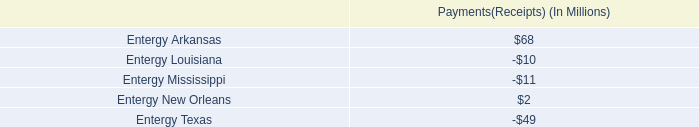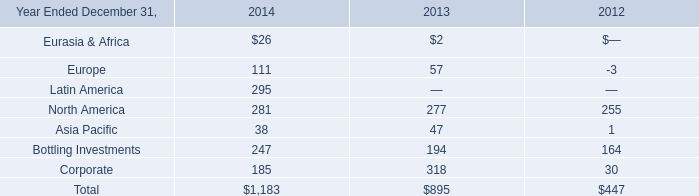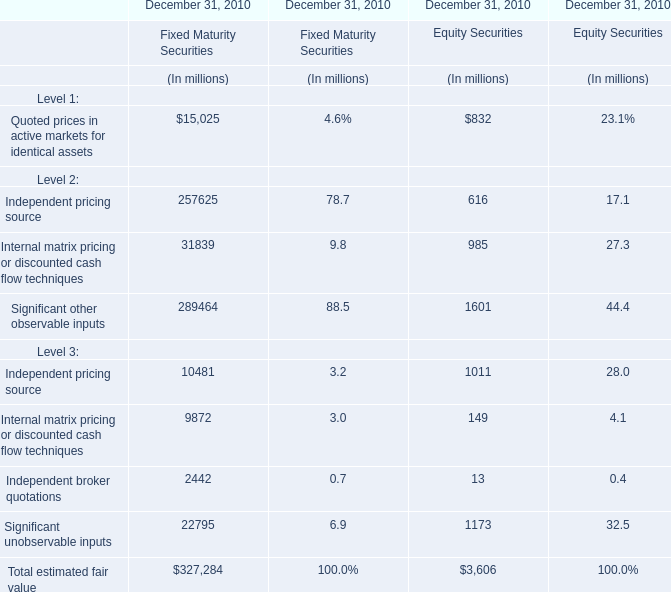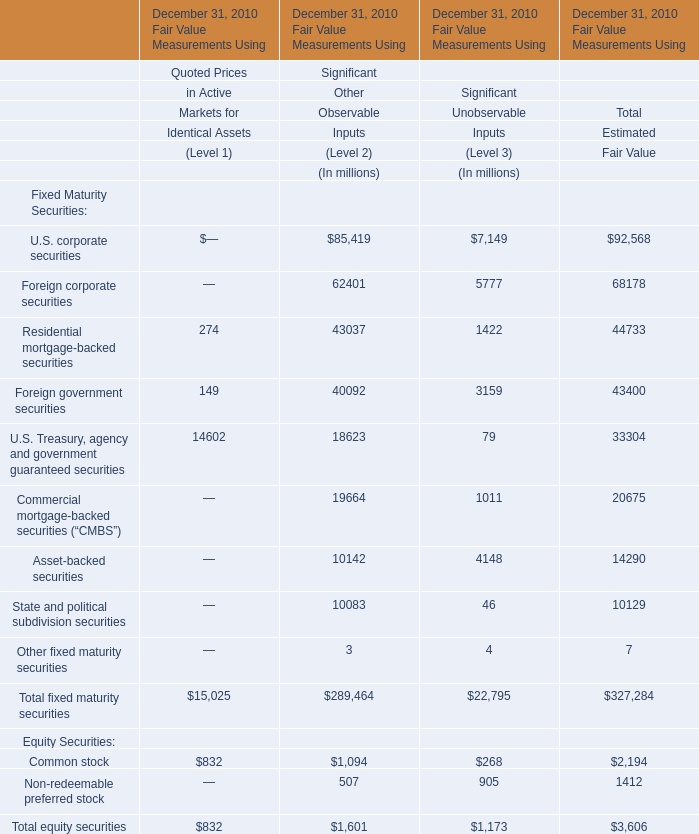Which Level is Independent pricing source for Equity Securities in terms of value at December 31, 2010 more between Level 2 and Level 3 ? 
Answer: 3. 